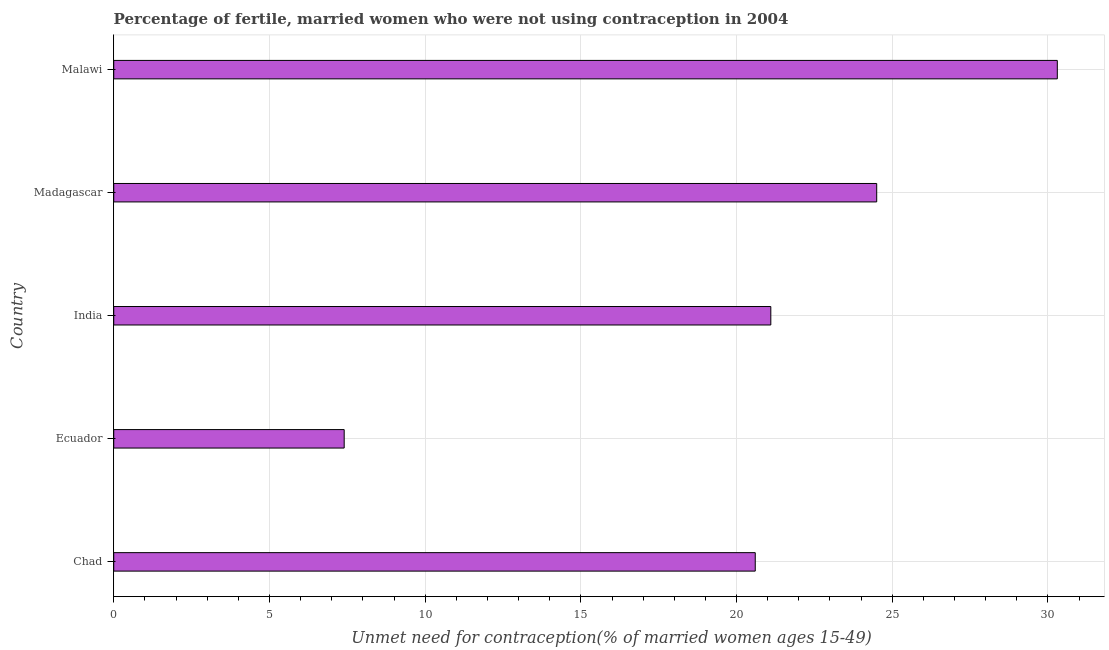Does the graph contain any zero values?
Provide a short and direct response. No. Does the graph contain grids?
Make the answer very short. Yes. What is the title of the graph?
Offer a very short reply. Percentage of fertile, married women who were not using contraception in 2004. What is the label or title of the X-axis?
Offer a terse response.  Unmet need for contraception(% of married women ages 15-49). What is the number of married women who are not using contraception in Malawi?
Your answer should be very brief. 30.3. Across all countries, what is the maximum number of married women who are not using contraception?
Offer a very short reply. 30.3. Across all countries, what is the minimum number of married women who are not using contraception?
Your answer should be very brief. 7.4. In which country was the number of married women who are not using contraception maximum?
Your response must be concise. Malawi. In which country was the number of married women who are not using contraception minimum?
Make the answer very short. Ecuador. What is the sum of the number of married women who are not using contraception?
Your answer should be compact. 103.9. What is the difference between the number of married women who are not using contraception in Ecuador and Madagascar?
Provide a succinct answer. -17.1. What is the average number of married women who are not using contraception per country?
Your answer should be very brief. 20.78. What is the median number of married women who are not using contraception?
Your answer should be compact. 21.1. What is the ratio of the number of married women who are not using contraception in Ecuador to that in Malawi?
Your answer should be compact. 0.24. Is the number of married women who are not using contraception in India less than that in Malawi?
Offer a very short reply. Yes. What is the difference between the highest and the second highest number of married women who are not using contraception?
Offer a terse response. 5.8. Is the sum of the number of married women who are not using contraception in Ecuador and India greater than the maximum number of married women who are not using contraception across all countries?
Offer a terse response. No. What is the difference between the highest and the lowest number of married women who are not using contraception?
Your answer should be compact. 22.9. In how many countries, is the number of married women who are not using contraception greater than the average number of married women who are not using contraception taken over all countries?
Your answer should be very brief. 3. Are all the bars in the graph horizontal?
Make the answer very short. Yes. How many countries are there in the graph?
Your response must be concise. 5. What is the difference between two consecutive major ticks on the X-axis?
Provide a short and direct response. 5. What is the  Unmet need for contraception(% of married women ages 15-49) of Chad?
Provide a succinct answer. 20.6. What is the  Unmet need for contraception(% of married women ages 15-49) in India?
Your response must be concise. 21.1. What is the  Unmet need for contraception(% of married women ages 15-49) of Malawi?
Offer a very short reply. 30.3. What is the difference between the  Unmet need for contraception(% of married women ages 15-49) in Chad and India?
Provide a short and direct response. -0.5. What is the difference between the  Unmet need for contraception(% of married women ages 15-49) in Chad and Madagascar?
Your response must be concise. -3.9. What is the difference between the  Unmet need for contraception(% of married women ages 15-49) in Chad and Malawi?
Provide a short and direct response. -9.7. What is the difference between the  Unmet need for contraception(% of married women ages 15-49) in Ecuador and India?
Provide a short and direct response. -13.7. What is the difference between the  Unmet need for contraception(% of married women ages 15-49) in Ecuador and Madagascar?
Your response must be concise. -17.1. What is the difference between the  Unmet need for contraception(% of married women ages 15-49) in Ecuador and Malawi?
Offer a terse response. -22.9. What is the difference between the  Unmet need for contraception(% of married women ages 15-49) in India and Madagascar?
Your answer should be compact. -3.4. What is the difference between the  Unmet need for contraception(% of married women ages 15-49) in India and Malawi?
Provide a short and direct response. -9.2. What is the difference between the  Unmet need for contraception(% of married women ages 15-49) in Madagascar and Malawi?
Give a very brief answer. -5.8. What is the ratio of the  Unmet need for contraception(% of married women ages 15-49) in Chad to that in Ecuador?
Keep it short and to the point. 2.78. What is the ratio of the  Unmet need for contraception(% of married women ages 15-49) in Chad to that in Madagascar?
Provide a short and direct response. 0.84. What is the ratio of the  Unmet need for contraception(% of married women ages 15-49) in Chad to that in Malawi?
Give a very brief answer. 0.68. What is the ratio of the  Unmet need for contraception(% of married women ages 15-49) in Ecuador to that in India?
Give a very brief answer. 0.35. What is the ratio of the  Unmet need for contraception(% of married women ages 15-49) in Ecuador to that in Madagascar?
Offer a very short reply. 0.3. What is the ratio of the  Unmet need for contraception(% of married women ages 15-49) in Ecuador to that in Malawi?
Provide a succinct answer. 0.24. What is the ratio of the  Unmet need for contraception(% of married women ages 15-49) in India to that in Madagascar?
Provide a succinct answer. 0.86. What is the ratio of the  Unmet need for contraception(% of married women ages 15-49) in India to that in Malawi?
Keep it short and to the point. 0.7. What is the ratio of the  Unmet need for contraception(% of married women ages 15-49) in Madagascar to that in Malawi?
Offer a very short reply. 0.81. 